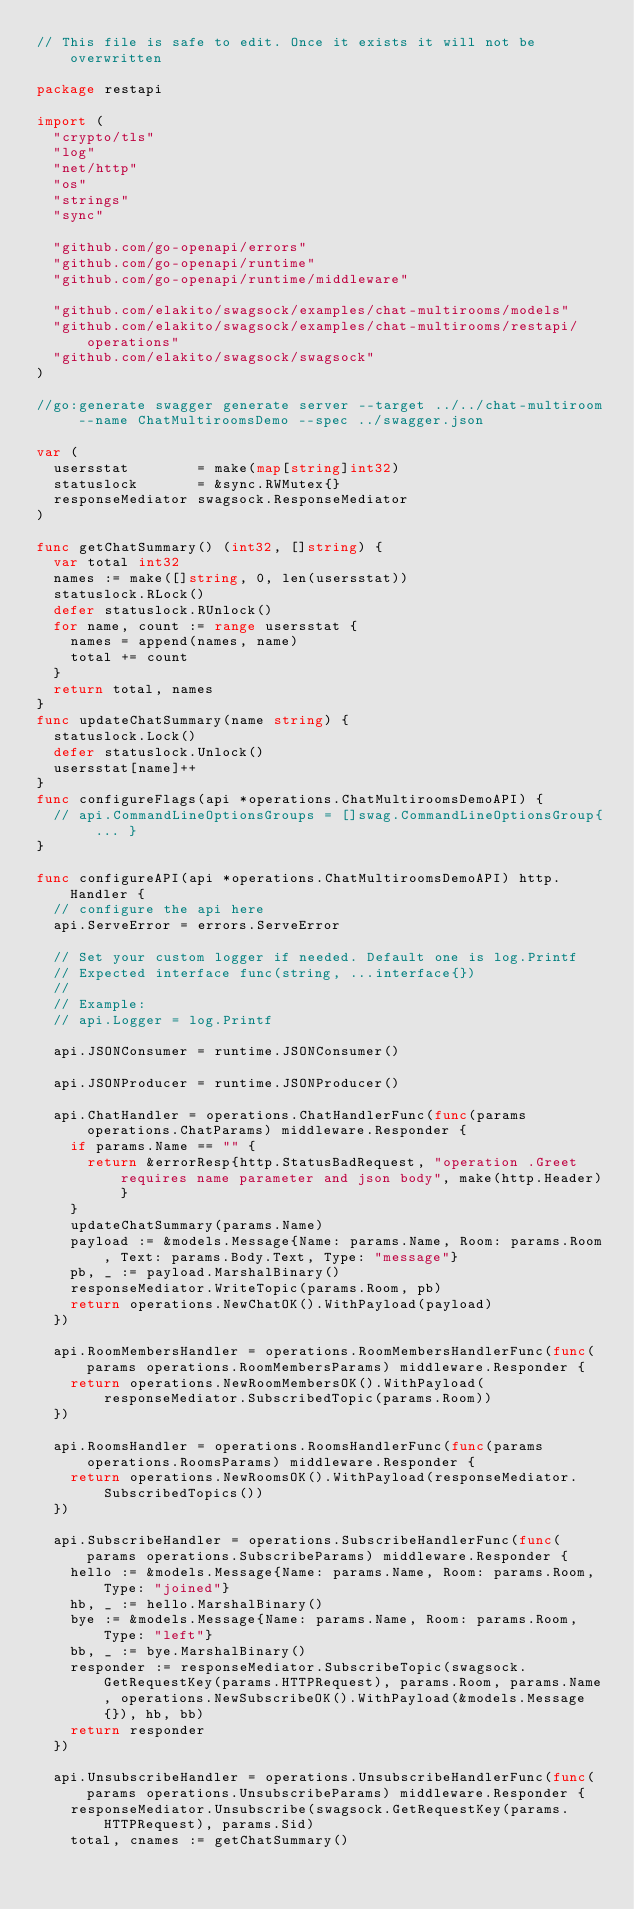<code> <loc_0><loc_0><loc_500><loc_500><_Go_>// This file is safe to edit. Once it exists it will not be overwritten

package restapi

import (
	"crypto/tls"
	"log"
	"net/http"
	"os"
	"strings"
	"sync"

	"github.com/go-openapi/errors"
	"github.com/go-openapi/runtime"
	"github.com/go-openapi/runtime/middleware"

	"github.com/elakito/swagsock/examples/chat-multirooms/models"
	"github.com/elakito/swagsock/examples/chat-multirooms/restapi/operations"
	"github.com/elakito/swagsock/swagsock"
)

//go:generate swagger generate server --target ../../chat-multiroom --name ChatMultiroomsDemo --spec ../swagger.json

var (
	usersstat        = make(map[string]int32)
	statuslock       = &sync.RWMutex{}
	responseMediator swagsock.ResponseMediator
)

func getChatSummary() (int32, []string) {
	var total int32
	names := make([]string, 0, len(usersstat))
	statuslock.RLock()
	defer statuslock.RUnlock()
	for name, count := range usersstat {
		names = append(names, name)
		total += count
	}
	return total, names
}
func updateChatSummary(name string) {
	statuslock.Lock()
	defer statuslock.Unlock()
	usersstat[name]++
}
func configureFlags(api *operations.ChatMultiroomsDemoAPI) {
	// api.CommandLineOptionsGroups = []swag.CommandLineOptionsGroup{ ... }
}

func configureAPI(api *operations.ChatMultiroomsDemoAPI) http.Handler {
	// configure the api here
	api.ServeError = errors.ServeError

	// Set your custom logger if needed. Default one is log.Printf
	// Expected interface func(string, ...interface{})
	//
	// Example:
	// api.Logger = log.Printf

	api.JSONConsumer = runtime.JSONConsumer()

	api.JSONProducer = runtime.JSONProducer()

	api.ChatHandler = operations.ChatHandlerFunc(func(params operations.ChatParams) middleware.Responder {
		if params.Name == "" {
			return &errorResp{http.StatusBadRequest, "operation .Greet requires name parameter and json body", make(http.Header)}
		}
		updateChatSummary(params.Name)
		payload := &models.Message{Name: params.Name, Room: params.Room, Text: params.Body.Text, Type: "message"}
		pb, _ := payload.MarshalBinary()
		responseMediator.WriteTopic(params.Room, pb)
		return operations.NewChatOK().WithPayload(payload)
	})

	api.RoomMembersHandler = operations.RoomMembersHandlerFunc(func(params operations.RoomMembersParams) middleware.Responder {
		return operations.NewRoomMembersOK().WithPayload(responseMediator.SubscribedTopic(params.Room))
	})

	api.RoomsHandler = operations.RoomsHandlerFunc(func(params operations.RoomsParams) middleware.Responder {
		return operations.NewRoomsOK().WithPayload(responseMediator.SubscribedTopics())
	})

	api.SubscribeHandler = operations.SubscribeHandlerFunc(func(params operations.SubscribeParams) middleware.Responder {
		hello := &models.Message{Name: params.Name, Room: params.Room, Type: "joined"}
		hb, _ := hello.MarshalBinary()
		bye := &models.Message{Name: params.Name, Room: params.Room, Type: "left"}
		bb, _ := bye.MarshalBinary()
		responder := responseMediator.SubscribeTopic(swagsock.GetRequestKey(params.HTTPRequest), params.Room, params.Name, operations.NewSubscribeOK().WithPayload(&models.Message{}), hb, bb)
		return responder
	})

	api.UnsubscribeHandler = operations.UnsubscribeHandlerFunc(func(params operations.UnsubscribeParams) middleware.Responder {
		responseMediator.Unsubscribe(swagsock.GetRequestKey(params.HTTPRequest), params.Sid)
		total, cnames := getChatSummary()</code> 